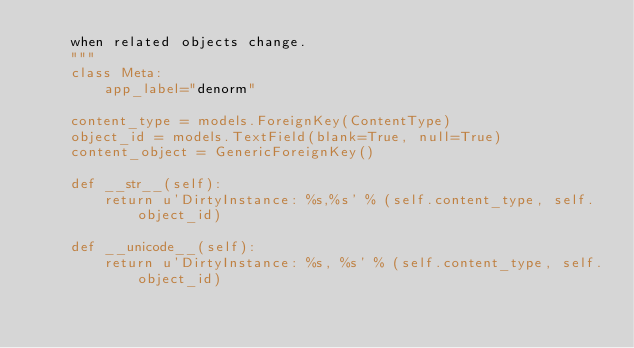Convert code to text. <code><loc_0><loc_0><loc_500><loc_500><_Python_>    when related objects change.
    """
    class Meta:
        app_label="denorm"

    content_type = models.ForeignKey(ContentType)
    object_id = models.TextField(blank=True, null=True)
    content_object = GenericForeignKey()

    def __str__(self):
        return u'DirtyInstance: %s,%s' % (self.content_type, self.object_id)

    def __unicode__(self):
        return u'DirtyInstance: %s, %s' % (self.content_type, self.object_id)
</code> 